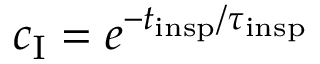<formula> <loc_0><loc_0><loc_500><loc_500>c _ { I } = e ^ { - t _ { i n s p } / \tau _ { i n s p } }</formula> 